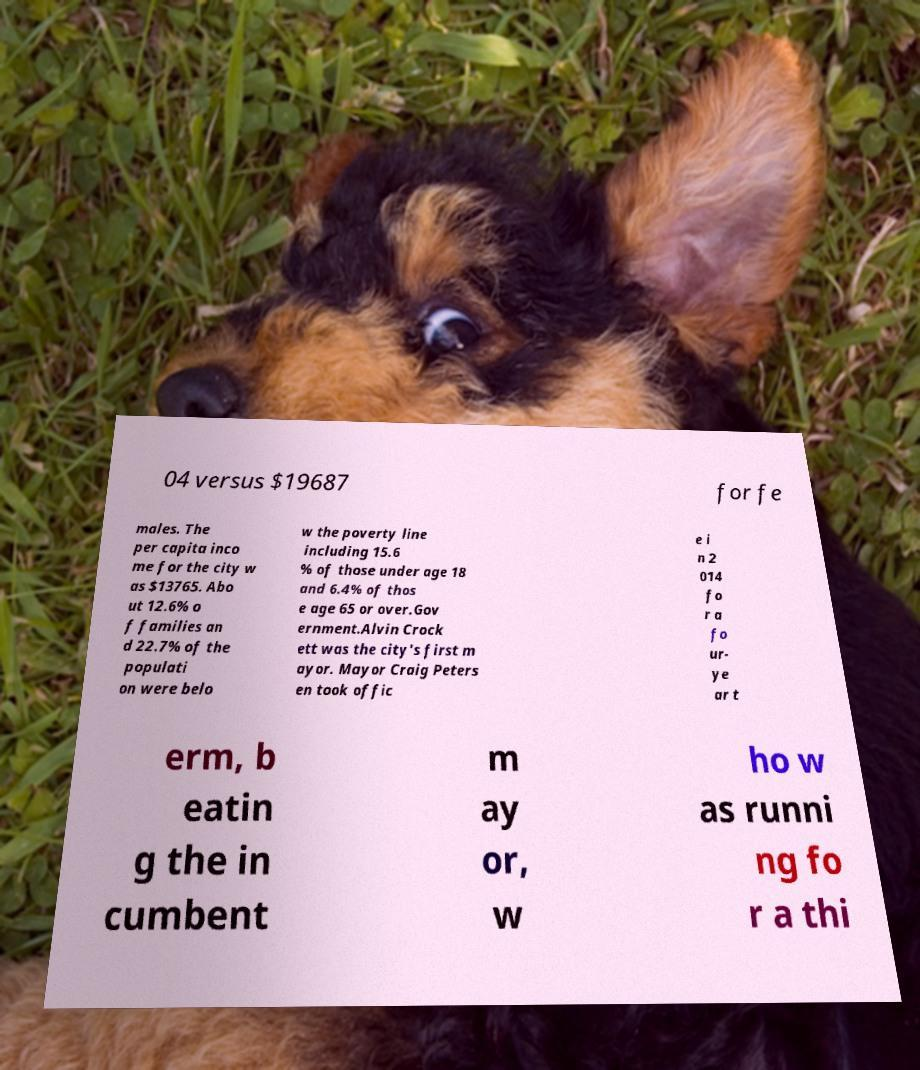Please identify and transcribe the text found in this image. 04 versus $19687 for fe males. The per capita inco me for the city w as $13765. Abo ut 12.6% o f families an d 22.7% of the populati on were belo w the poverty line including 15.6 % of those under age 18 and 6.4% of thos e age 65 or over.Gov ernment.Alvin Crock ett was the city's first m ayor. Mayor Craig Peters en took offic e i n 2 014 fo r a fo ur- ye ar t erm, b eatin g the in cumbent m ay or, w ho w as runni ng fo r a thi 